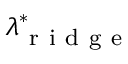Convert formula to latex. <formula><loc_0><loc_0><loc_500><loc_500>\lambda _ { r i d g e } ^ { * }</formula> 